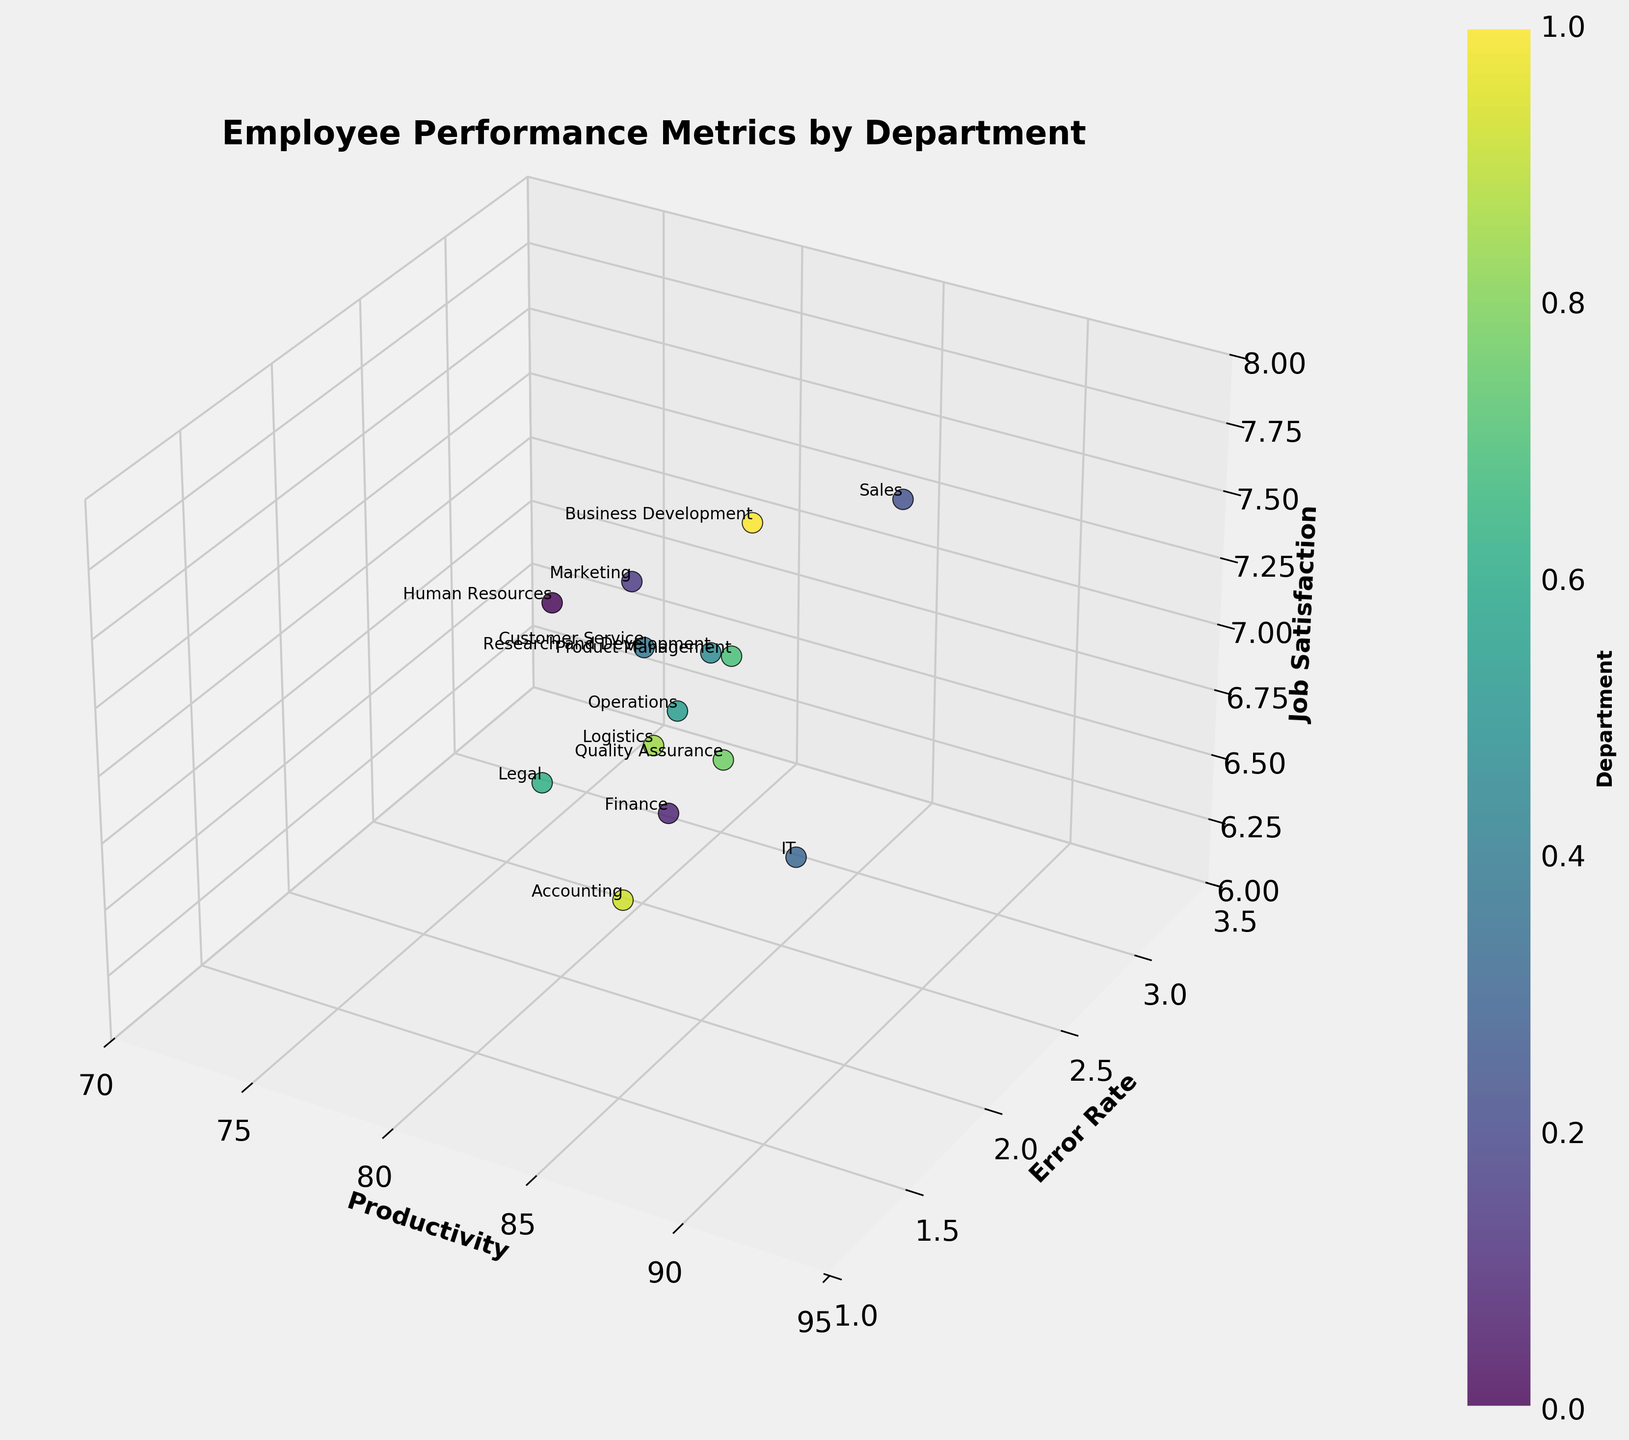What is the title of the 3D scatter plot? The title is displayed at the top of the plot, which provides the context of the data.
Answer: Employee Performance Metrics by Department How many departments are represented in the scatter plot? By counting the descriptive labels of departments on the scatter points, there are 14 different departments.
Answer: 14 Which department has the highest job satisfaction? Job Satisfaction is represented on the z-axis. The Sales department, with a job satisfaction of 7.8, is positioned highest on the z-axis.
Answer: Sales What is the error rate of the IT department? The Error Rate is represented on the y-axis. The IT department has an error rate of 1.5, as shown on the scatter point labeled 'IT'.
Answer: 1.5 Compare the productivity of the Finance and Customer Service departments. The Finance department has a productivity score of 85, while the Customer Service department has a productivity score of 76, which can be seen along the x-axis.
Answer: Finance has higher productivity Which department has the lowest error rate? The lowest point on the y-axis corresponds to the lowest error rate. The IT department has the lowest error rate of 1.5.
Answer: IT Which department has the highest combination of productivity and job satisfaction? By looking at the positions on both the x-axis (Productivity) and the z-axis (Job Satisfaction), the IT department stands out with high values in both domains: 91 for productivity and 7.1 for job satisfaction.
Answer: IT Is there any department with a productivity score above 90? The scatter points with x-axis values greater than 90 show departments with high productivity. The IT department has a productivity score of 91.
Answer: IT What is the average job satisfaction across all departments? Sum the job satisfaction scores for all departments and divide by the number of departments: (7.2 + 6.9 + 7.5 + 7.8 + 7.1 + 6.5 + 7.6 + 7.0 + 6.8 + 7.4 + 7.3 + 6.7 + 6.6 + 7.7) / 14 = 99.1 / 14 ≈ 7.08.
Answer: 7.08 What is the difference in job satisfaction between Marketing and Customer Service departments? Job Satisfaction for Marketing is 7.5 and for Customer Service is 6.5. By subtracting the two values (7.5 - 6.5), we get a difference of 1.0.
Answer: 1.0 